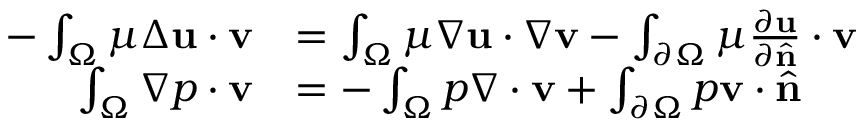Convert formula to latex. <formula><loc_0><loc_0><loc_500><loc_500>{ \begin{array} { r l } { - \int _ { \Omega } \mu \Delta u \cdot v } & { = \int _ { \Omega } \mu \nabla u \cdot \nabla v - \int _ { \partial \Omega } \mu { \frac { \partial u } { \partial { \hat { n } } } } \cdot v } \\ { \int _ { \Omega } \nabla p \cdot v } & { = - \int _ { \Omega } p \nabla \cdot v + \int _ { \partial \Omega } p v \cdot { \hat { n } } } \end{array} }</formula> 